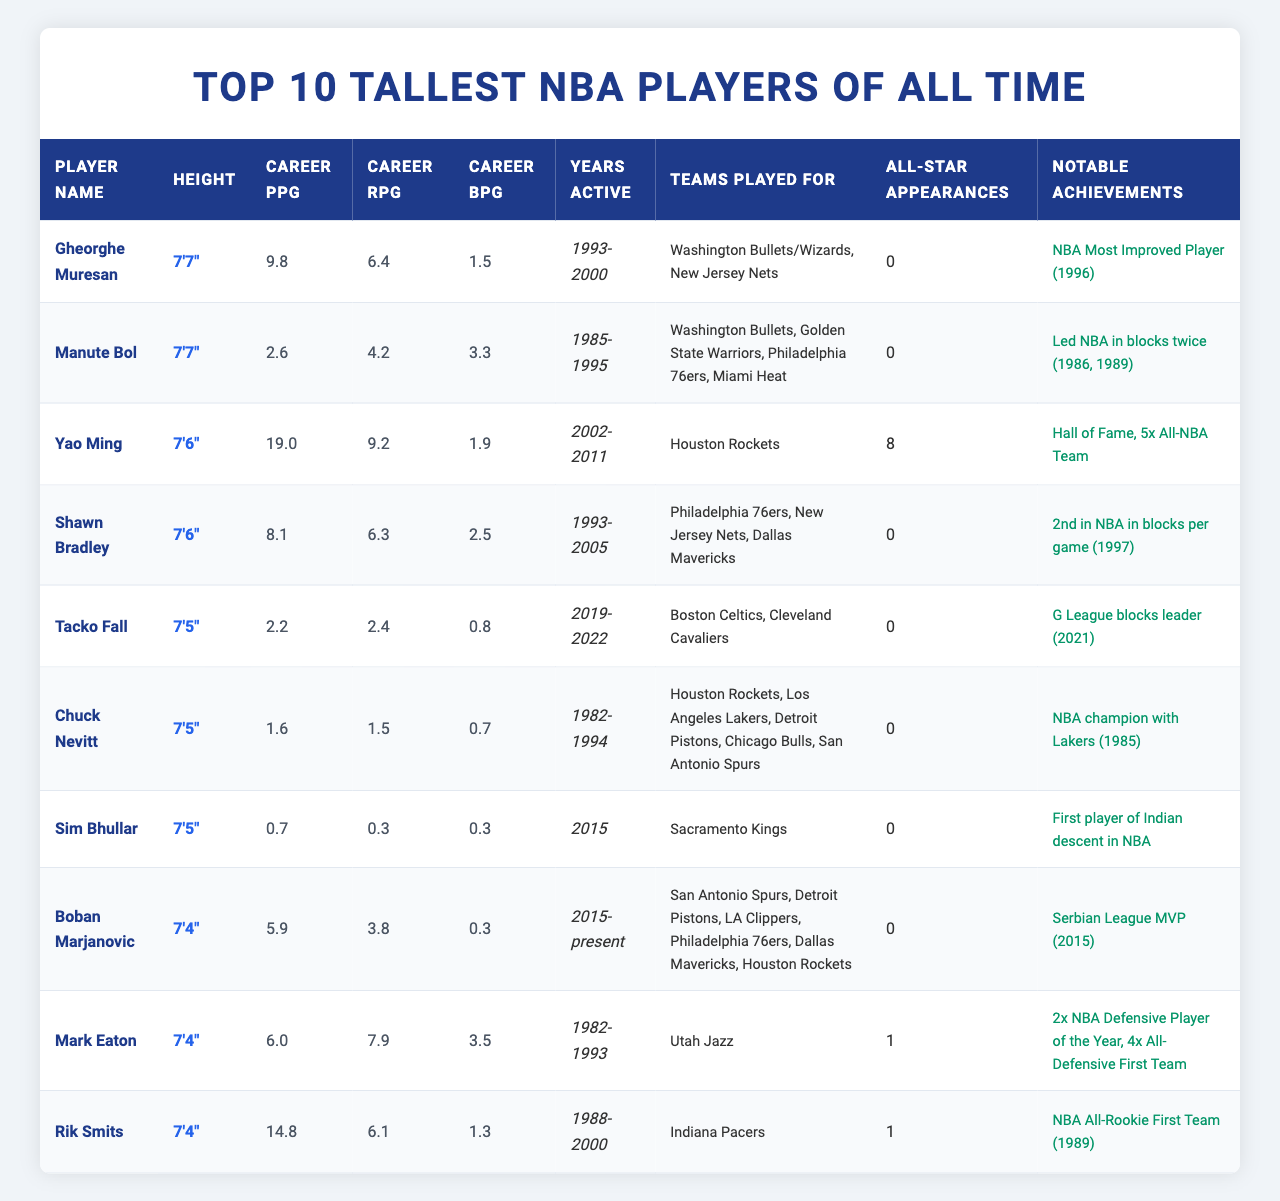What is the height of Gheorghe Muresan? The table lists Gheorghe Muresan's height in the "Height" column, which shows "7'7\"."
Answer: 7'7" How many All-Star appearances did Yao Ming have during his career? According to the "All-Star Appearances" column, Yao Ming is noted to have had "8" appearances.
Answer: 8 Which player has the highest career points per game (PPG)? By checking the "Career PPG" column, Yao Ming's average of "19.0" is the highest among the players listed.
Answer: Yao Ming What is the average career rebounds per game (RPG) of the top 10 tallest players? To find the average, sum the RPG values: 6.4 + 4.2 + 9.2 + 6.3 + 2.4 + 1.5 + 0.3 + 3.8 + 7.9 + 6.1 = 43.2. Then divide by 10, resulting in 4.32.
Answer: 4.32 Who led the NBA in blocks per game in the years both Manute Bol and Shawn Bradley played? The table shows Manute Bol averaged "3.3" BPG and Shawn Bradley averaged "2.5" BPG. Manute Bol led the league in blocks during his active years (1985-1995).
Answer: Manute Bol Is it true that all the players listed have had at least one All-Star appearance? Checking the "All-Star Appearances" column reveals that several players, including Gheorghe Muresan and Manute Bol, have "0" appearances, thus making the statement false.
Answer: No Which player among the tallest had the shortest active playing years? Looking at the "Years Active" column, Sim Bhullar played for just "1" year in 2015, which is shorter than any other player on the list.
Answer: Sim Bhullar Calculate the combined career points per game (PPG) of the players who are taller than 7'5". The players taller than 7'5" are Gheorghe Muresan, Manute Bol, Yao Ming, and Shawn Bradley. Their PPGs add up to 9.8 + 2.6 + 19.0 + 8.1 = 39.5.
Answer: 39.5 Which team did Boban Marjanovic play for the longest based on the data? The "Teams Played For" column states that Boban played for six teams, but he is currently active, indicating he may have played longest for the teams listed in the latter part of the table. Given the names, we can't determine based on just the counts.
Answer: Uncertain Identify the player with the highest career blocks per game (BPG). The "Career BPG" column indicates that Manute Bol, with "3.3" BPG, has the highest average for blocks per game.
Answer: Manute Bol 